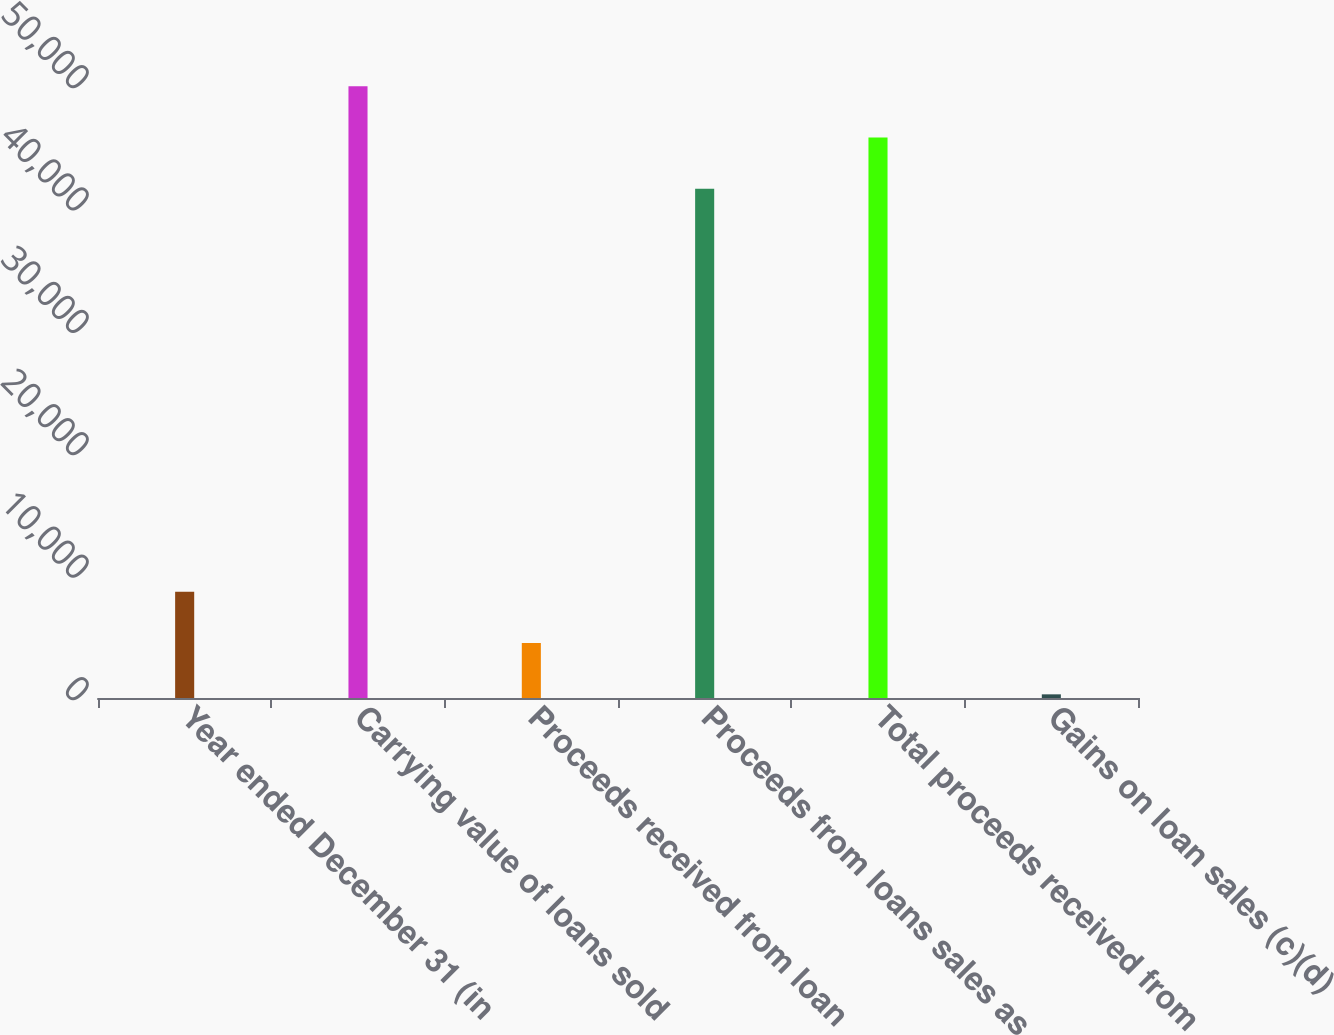Convert chart to OTSL. <chart><loc_0><loc_0><loc_500><loc_500><bar_chart><fcel>Year ended December 31 (in<fcel>Carrying value of loans sold<fcel>Proceeds received from loan<fcel>Proceeds from loans sales as<fcel>Total proceeds received from<fcel>Gains on loan sales (c)(d)<nl><fcel>8671.4<fcel>49987.4<fcel>4485.2<fcel>41615<fcel>45801.2<fcel>299<nl></chart> 